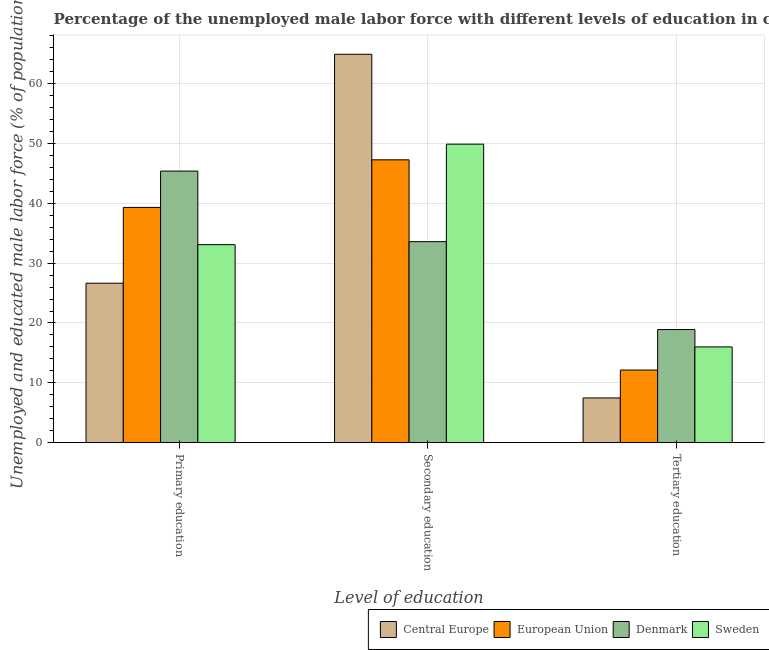How many bars are there on the 1st tick from the left?
Your response must be concise. 4. What is the label of the 3rd group of bars from the left?
Your response must be concise. Tertiary education. What is the percentage of male labor force who received primary education in Central Europe?
Offer a very short reply. 26.65. Across all countries, what is the maximum percentage of male labor force who received tertiary education?
Give a very brief answer. 18.9. Across all countries, what is the minimum percentage of male labor force who received primary education?
Your answer should be compact. 26.65. In which country was the percentage of male labor force who received secondary education maximum?
Ensure brevity in your answer.  Central Europe. In which country was the percentage of male labor force who received tertiary education minimum?
Your answer should be very brief. Central Europe. What is the total percentage of male labor force who received primary education in the graph?
Offer a terse response. 144.48. What is the difference between the percentage of male labor force who received tertiary education in European Union and that in Denmark?
Offer a terse response. -6.77. What is the difference between the percentage of male labor force who received primary education in Denmark and the percentage of male labor force who received tertiary education in Central Europe?
Keep it short and to the point. 37.93. What is the average percentage of male labor force who received tertiary education per country?
Provide a succinct answer. 13.63. What is the difference between the percentage of male labor force who received tertiary education and percentage of male labor force who received primary education in Central Europe?
Make the answer very short. -19.18. In how many countries, is the percentage of male labor force who received tertiary education greater than 64 %?
Give a very brief answer. 0. What is the ratio of the percentage of male labor force who received tertiary education in Denmark to that in Central Europe?
Your response must be concise. 2.53. Is the percentage of male labor force who received secondary education in European Union less than that in Sweden?
Keep it short and to the point. Yes. What is the difference between the highest and the second highest percentage of male labor force who received primary education?
Make the answer very short. 6.07. What is the difference between the highest and the lowest percentage of male labor force who received tertiary education?
Ensure brevity in your answer.  11.43. Is the sum of the percentage of male labor force who received tertiary education in Central Europe and Sweden greater than the maximum percentage of male labor force who received secondary education across all countries?
Offer a very short reply. No. What does the 1st bar from the left in Tertiary education represents?
Provide a short and direct response. Central Europe. What does the 1st bar from the right in Secondary education represents?
Make the answer very short. Sweden. How many bars are there?
Provide a succinct answer. 12. Are all the bars in the graph horizontal?
Provide a short and direct response. No. What is the difference between two consecutive major ticks on the Y-axis?
Offer a very short reply. 10. Are the values on the major ticks of Y-axis written in scientific E-notation?
Provide a short and direct response. No. Does the graph contain any zero values?
Give a very brief answer. No. Does the graph contain grids?
Give a very brief answer. Yes. Where does the legend appear in the graph?
Provide a succinct answer. Bottom right. How many legend labels are there?
Offer a terse response. 4. How are the legend labels stacked?
Give a very brief answer. Horizontal. What is the title of the graph?
Provide a succinct answer. Percentage of the unemployed male labor force with different levels of education in countries. What is the label or title of the X-axis?
Ensure brevity in your answer.  Level of education. What is the label or title of the Y-axis?
Make the answer very short. Unemployed and educated male labor force (% of population). What is the Unemployed and educated male labor force (% of population) in Central Europe in Primary education?
Your response must be concise. 26.65. What is the Unemployed and educated male labor force (% of population) in European Union in Primary education?
Your response must be concise. 39.33. What is the Unemployed and educated male labor force (% of population) in Denmark in Primary education?
Your answer should be compact. 45.4. What is the Unemployed and educated male labor force (% of population) of Sweden in Primary education?
Keep it short and to the point. 33.1. What is the Unemployed and educated male labor force (% of population) of Central Europe in Secondary education?
Give a very brief answer. 64.93. What is the Unemployed and educated male labor force (% of population) in European Union in Secondary education?
Offer a very short reply. 47.28. What is the Unemployed and educated male labor force (% of population) in Denmark in Secondary education?
Provide a succinct answer. 33.6. What is the Unemployed and educated male labor force (% of population) in Sweden in Secondary education?
Your answer should be compact. 49.9. What is the Unemployed and educated male labor force (% of population) in Central Europe in Tertiary education?
Your answer should be compact. 7.47. What is the Unemployed and educated male labor force (% of population) in European Union in Tertiary education?
Your answer should be compact. 12.13. What is the Unemployed and educated male labor force (% of population) of Denmark in Tertiary education?
Offer a terse response. 18.9. Across all Level of education, what is the maximum Unemployed and educated male labor force (% of population) in Central Europe?
Give a very brief answer. 64.93. Across all Level of education, what is the maximum Unemployed and educated male labor force (% of population) of European Union?
Make the answer very short. 47.28. Across all Level of education, what is the maximum Unemployed and educated male labor force (% of population) of Denmark?
Provide a short and direct response. 45.4. Across all Level of education, what is the maximum Unemployed and educated male labor force (% of population) of Sweden?
Give a very brief answer. 49.9. Across all Level of education, what is the minimum Unemployed and educated male labor force (% of population) of Central Europe?
Provide a short and direct response. 7.47. Across all Level of education, what is the minimum Unemployed and educated male labor force (% of population) in European Union?
Your answer should be compact. 12.13. Across all Level of education, what is the minimum Unemployed and educated male labor force (% of population) in Denmark?
Your answer should be very brief. 18.9. What is the total Unemployed and educated male labor force (% of population) of Central Europe in the graph?
Make the answer very short. 99.05. What is the total Unemployed and educated male labor force (% of population) in European Union in the graph?
Make the answer very short. 98.74. What is the total Unemployed and educated male labor force (% of population) in Denmark in the graph?
Make the answer very short. 97.9. What is the total Unemployed and educated male labor force (% of population) in Sweden in the graph?
Your response must be concise. 99. What is the difference between the Unemployed and educated male labor force (% of population) of Central Europe in Primary education and that in Secondary education?
Your response must be concise. -38.28. What is the difference between the Unemployed and educated male labor force (% of population) of European Union in Primary education and that in Secondary education?
Give a very brief answer. -7.96. What is the difference between the Unemployed and educated male labor force (% of population) of Sweden in Primary education and that in Secondary education?
Provide a succinct answer. -16.8. What is the difference between the Unemployed and educated male labor force (% of population) in Central Europe in Primary education and that in Tertiary education?
Your answer should be compact. 19.18. What is the difference between the Unemployed and educated male labor force (% of population) of European Union in Primary education and that in Tertiary education?
Provide a short and direct response. 27.19. What is the difference between the Unemployed and educated male labor force (% of population) in Central Europe in Secondary education and that in Tertiary education?
Keep it short and to the point. 57.46. What is the difference between the Unemployed and educated male labor force (% of population) of European Union in Secondary education and that in Tertiary education?
Your answer should be very brief. 35.15. What is the difference between the Unemployed and educated male labor force (% of population) of Denmark in Secondary education and that in Tertiary education?
Your answer should be very brief. 14.7. What is the difference between the Unemployed and educated male labor force (% of population) in Sweden in Secondary education and that in Tertiary education?
Provide a short and direct response. 33.9. What is the difference between the Unemployed and educated male labor force (% of population) of Central Europe in Primary education and the Unemployed and educated male labor force (% of population) of European Union in Secondary education?
Offer a terse response. -20.63. What is the difference between the Unemployed and educated male labor force (% of population) in Central Europe in Primary education and the Unemployed and educated male labor force (% of population) in Denmark in Secondary education?
Make the answer very short. -6.95. What is the difference between the Unemployed and educated male labor force (% of population) of Central Europe in Primary education and the Unemployed and educated male labor force (% of population) of Sweden in Secondary education?
Make the answer very short. -23.25. What is the difference between the Unemployed and educated male labor force (% of population) of European Union in Primary education and the Unemployed and educated male labor force (% of population) of Denmark in Secondary education?
Your answer should be compact. 5.73. What is the difference between the Unemployed and educated male labor force (% of population) in European Union in Primary education and the Unemployed and educated male labor force (% of population) in Sweden in Secondary education?
Keep it short and to the point. -10.57. What is the difference between the Unemployed and educated male labor force (% of population) in Denmark in Primary education and the Unemployed and educated male labor force (% of population) in Sweden in Secondary education?
Give a very brief answer. -4.5. What is the difference between the Unemployed and educated male labor force (% of population) in Central Europe in Primary education and the Unemployed and educated male labor force (% of population) in European Union in Tertiary education?
Your answer should be very brief. 14.52. What is the difference between the Unemployed and educated male labor force (% of population) in Central Europe in Primary education and the Unemployed and educated male labor force (% of population) in Denmark in Tertiary education?
Offer a very short reply. 7.75. What is the difference between the Unemployed and educated male labor force (% of population) in Central Europe in Primary education and the Unemployed and educated male labor force (% of population) in Sweden in Tertiary education?
Your answer should be compact. 10.65. What is the difference between the Unemployed and educated male labor force (% of population) of European Union in Primary education and the Unemployed and educated male labor force (% of population) of Denmark in Tertiary education?
Your answer should be very brief. 20.43. What is the difference between the Unemployed and educated male labor force (% of population) of European Union in Primary education and the Unemployed and educated male labor force (% of population) of Sweden in Tertiary education?
Give a very brief answer. 23.33. What is the difference between the Unemployed and educated male labor force (% of population) in Denmark in Primary education and the Unemployed and educated male labor force (% of population) in Sweden in Tertiary education?
Provide a short and direct response. 29.4. What is the difference between the Unemployed and educated male labor force (% of population) in Central Europe in Secondary education and the Unemployed and educated male labor force (% of population) in European Union in Tertiary education?
Provide a short and direct response. 52.8. What is the difference between the Unemployed and educated male labor force (% of population) of Central Europe in Secondary education and the Unemployed and educated male labor force (% of population) of Denmark in Tertiary education?
Provide a succinct answer. 46.03. What is the difference between the Unemployed and educated male labor force (% of population) in Central Europe in Secondary education and the Unemployed and educated male labor force (% of population) in Sweden in Tertiary education?
Your answer should be compact. 48.93. What is the difference between the Unemployed and educated male labor force (% of population) in European Union in Secondary education and the Unemployed and educated male labor force (% of population) in Denmark in Tertiary education?
Ensure brevity in your answer.  28.38. What is the difference between the Unemployed and educated male labor force (% of population) in European Union in Secondary education and the Unemployed and educated male labor force (% of population) in Sweden in Tertiary education?
Your answer should be compact. 31.28. What is the difference between the Unemployed and educated male labor force (% of population) of Denmark in Secondary education and the Unemployed and educated male labor force (% of population) of Sweden in Tertiary education?
Offer a terse response. 17.6. What is the average Unemployed and educated male labor force (% of population) of Central Europe per Level of education?
Provide a succinct answer. 33.02. What is the average Unemployed and educated male labor force (% of population) in European Union per Level of education?
Give a very brief answer. 32.91. What is the average Unemployed and educated male labor force (% of population) in Denmark per Level of education?
Your answer should be compact. 32.63. What is the average Unemployed and educated male labor force (% of population) of Sweden per Level of education?
Ensure brevity in your answer.  33. What is the difference between the Unemployed and educated male labor force (% of population) of Central Europe and Unemployed and educated male labor force (% of population) of European Union in Primary education?
Provide a succinct answer. -12.68. What is the difference between the Unemployed and educated male labor force (% of population) of Central Europe and Unemployed and educated male labor force (% of population) of Denmark in Primary education?
Provide a short and direct response. -18.75. What is the difference between the Unemployed and educated male labor force (% of population) of Central Europe and Unemployed and educated male labor force (% of population) of Sweden in Primary education?
Ensure brevity in your answer.  -6.45. What is the difference between the Unemployed and educated male labor force (% of population) in European Union and Unemployed and educated male labor force (% of population) in Denmark in Primary education?
Offer a terse response. -6.07. What is the difference between the Unemployed and educated male labor force (% of population) of European Union and Unemployed and educated male labor force (% of population) of Sweden in Primary education?
Ensure brevity in your answer.  6.23. What is the difference between the Unemployed and educated male labor force (% of population) of Denmark and Unemployed and educated male labor force (% of population) of Sweden in Primary education?
Make the answer very short. 12.3. What is the difference between the Unemployed and educated male labor force (% of population) in Central Europe and Unemployed and educated male labor force (% of population) in European Union in Secondary education?
Make the answer very short. 17.65. What is the difference between the Unemployed and educated male labor force (% of population) in Central Europe and Unemployed and educated male labor force (% of population) in Denmark in Secondary education?
Give a very brief answer. 31.33. What is the difference between the Unemployed and educated male labor force (% of population) of Central Europe and Unemployed and educated male labor force (% of population) of Sweden in Secondary education?
Your response must be concise. 15.03. What is the difference between the Unemployed and educated male labor force (% of population) of European Union and Unemployed and educated male labor force (% of population) of Denmark in Secondary education?
Your response must be concise. 13.68. What is the difference between the Unemployed and educated male labor force (% of population) of European Union and Unemployed and educated male labor force (% of population) of Sweden in Secondary education?
Provide a short and direct response. -2.62. What is the difference between the Unemployed and educated male labor force (% of population) of Denmark and Unemployed and educated male labor force (% of population) of Sweden in Secondary education?
Offer a very short reply. -16.3. What is the difference between the Unemployed and educated male labor force (% of population) in Central Europe and Unemployed and educated male labor force (% of population) in European Union in Tertiary education?
Keep it short and to the point. -4.66. What is the difference between the Unemployed and educated male labor force (% of population) in Central Europe and Unemployed and educated male labor force (% of population) in Denmark in Tertiary education?
Offer a very short reply. -11.43. What is the difference between the Unemployed and educated male labor force (% of population) in Central Europe and Unemployed and educated male labor force (% of population) in Sweden in Tertiary education?
Your response must be concise. -8.53. What is the difference between the Unemployed and educated male labor force (% of population) in European Union and Unemployed and educated male labor force (% of population) in Denmark in Tertiary education?
Your answer should be very brief. -6.77. What is the difference between the Unemployed and educated male labor force (% of population) of European Union and Unemployed and educated male labor force (% of population) of Sweden in Tertiary education?
Offer a very short reply. -3.87. What is the difference between the Unemployed and educated male labor force (% of population) in Denmark and Unemployed and educated male labor force (% of population) in Sweden in Tertiary education?
Give a very brief answer. 2.9. What is the ratio of the Unemployed and educated male labor force (% of population) in Central Europe in Primary education to that in Secondary education?
Make the answer very short. 0.41. What is the ratio of the Unemployed and educated male labor force (% of population) of European Union in Primary education to that in Secondary education?
Your answer should be very brief. 0.83. What is the ratio of the Unemployed and educated male labor force (% of population) in Denmark in Primary education to that in Secondary education?
Provide a short and direct response. 1.35. What is the ratio of the Unemployed and educated male labor force (% of population) in Sweden in Primary education to that in Secondary education?
Make the answer very short. 0.66. What is the ratio of the Unemployed and educated male labor force (% of population) of Central Europe in Primary education to that in Tertiary education?
Your response must be concise. 3.57. What is the ratio of the Unemployed and educated male labor force (% of population) in European Union in Primary education to that in Tertiary education?
Provide a short and direct response. 3.24. What is the ratio of the Unemployed and educated male labor force (% of population) of Denmark in Primary education to that in Tertiary education?
Make the answer very short. 2.4. What is the ratio of the Unemployed and educated male labor force (% of population) in Sweden in Primary education to that in Tertiary education?
Ensure brevity in your answer.  2.07. What is the ratio of the Unemployed and educated male labor force (% of population) of Central Europe in Secondary education to that in Tertiary education?
Offer a terse response. 8.69. What is the ratio of the Unemployed and educated male labor force (% of population) of European Union in Secondary education to that in Tertiary education?
Your response must be concise. 3.9. What is the ratio of the Unemployed and educated male labor force (% of population) of Denmark in Secondary education to that in Tertiary education?
Provide a short and direct response. 1.78. What is the ratio of the Unemployed and educated male labor force (% of population) of Sweden in Secondary education to that in Tertiary education?
Provide a succinct answer. 3.12. What is the difference between the highest and the second highest Unemployed and educated male labor force (% of population) of Central Europe?
Provide a succinct answer. 38.28. What is the difference between the highest and the second highest Unemployed and educated male labor force (% of population) of European Union?
Provide a succinct answer. 7.96. What is the difference between the highest and the second highest Unemployed and educated male labor force (% of population) in Sweden?
Your answer should be very brief. 16.8. What is the difference between the highest and the lowest Unemployed and educated male labor force (% of population) of Central Europe?
Keep it short and to the point. 57.46. What is the difference between the highest and the lowest Unemployed and educated male labor force (% of population) of European Union?
Offer a terse response. 35.15. What is the difference between the highest and the lowest Unemployed and educated male labor force (% of population) in Sweden?
Give a very brief answer. 33.9. 